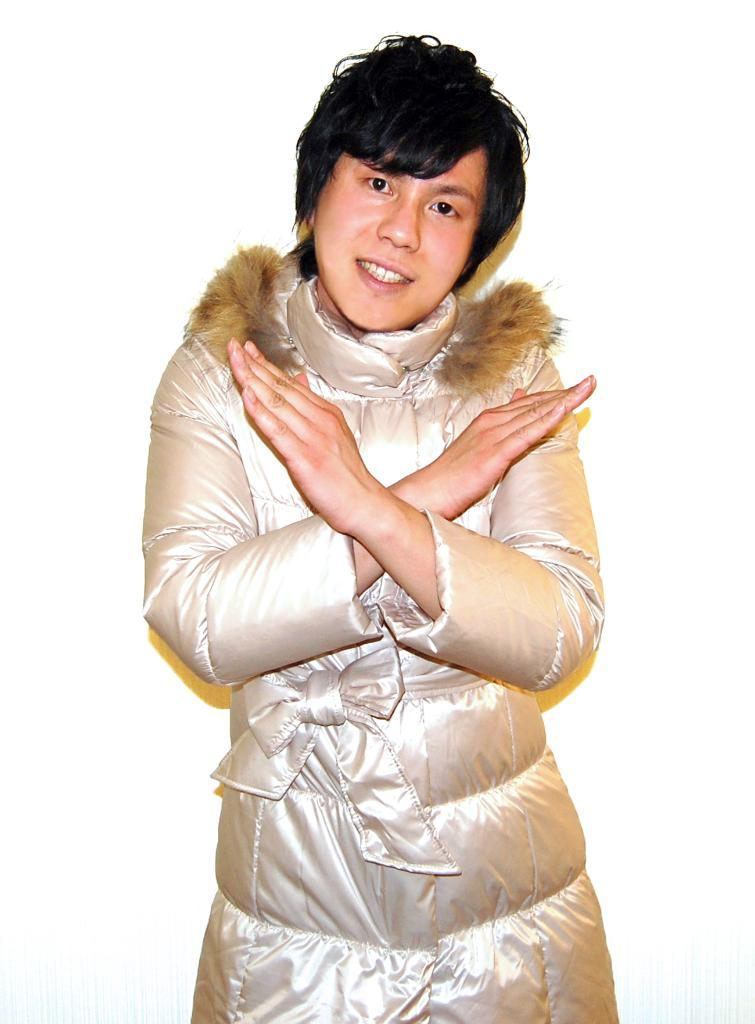Who or what is the main subject in the image? There is a person in the center of the image. What can be seen behind the person? There is a wall in the background of the image. What is the cast of the hour in the image? There is no cast or hour mentioned in the image, as it only features a person and a wall in the background. 